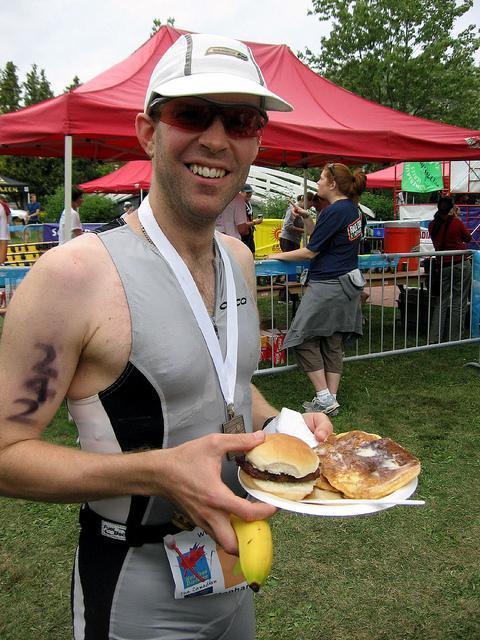How many people are there?
Give a very brief answer. 3. How many sandwiches can be seen?
Give a very brief answer. 2. How many skis is he using?
Give a very brief answer. 0. 